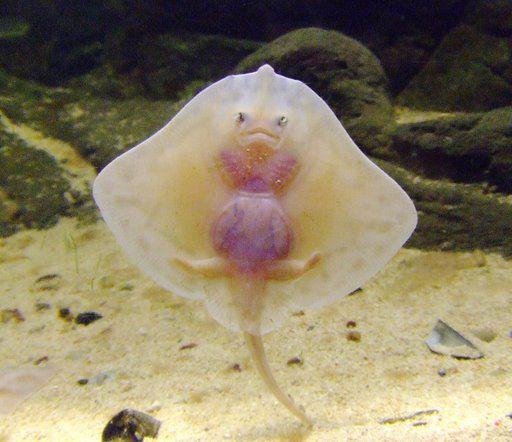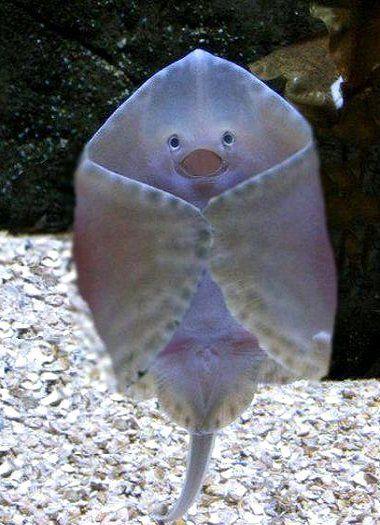The first image is the image on the left, the second image is the image on the right. Evaluate the accuracy of this statement regarding the images: "A single ray presses its body against the glass in each of the images.". Is it true? Answer yes or no. Yes. The first image is the image on the left, the second image is the image on the right. Considering the images on both sides, is "All of the stingrays are shown upright with undersides facing the camera and 'wings' outspread." valid? Answer yes or no. No. 